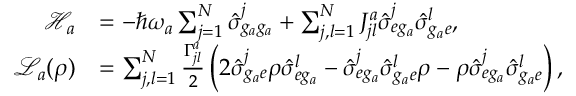Convert formula to latex. <formula><loc_0><loc_0><loc_500><loc_500>\begin{array} { r l } { \mathcal { H } _ { a } } & { = - \hbar { \omega } _ { a } \sum _ { j = 1 } ^ { N } \hat { \sigma } _ { g _ { a } g _ { a } } ^ { j } + \sum _ { j , l = 1 } ^ { N } J _ { j l } ^ { a } \hat { \sigma } _ { e g _ { a } } ^ { j } \hat { \sigma } _ { g _ { a } e } ^ { l } , } \\ { \mathcal { L } _ { a } ( \rho ) } & { = \sum _ { j , l = 1 } ^ { N } \frac { \Gamma _ { j l } ^ { a } } { 2 } \left ( 2 \hat { \sigma } _ { g _ { a } e } ^ { j } \rho \hat { \sigma } _ { e g _ { a } } ^ { l } - \hat { \sigma } _ { e g _ { a } } ^ { j } \hat { \sigma } _ { g _ { a } e } ^ { l } \rho - \rho \hat { \sigma } _ { e g _ { a } } ^ { j } \hat { \sigma } _ { g _ { a } e } ^ { l } \right ) , } \end{array}</formula> 